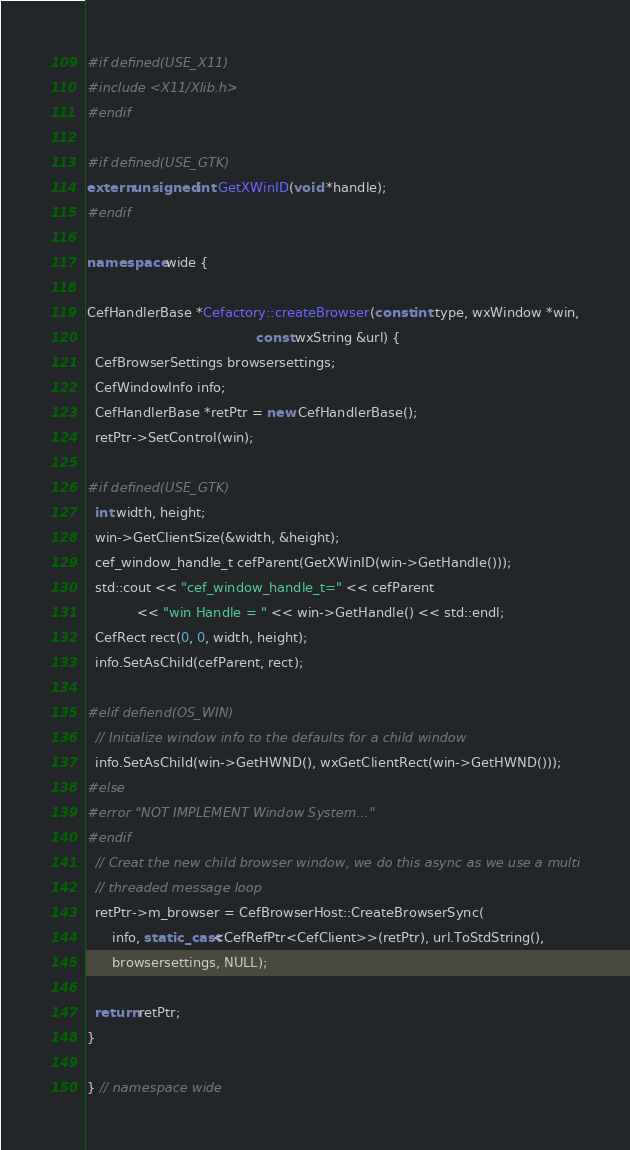Convert code to text. <code><loc_0><loc_0><loc_500><loc_500><_C++_>#if defined(USE_X11)
#include <X11/Xlib.h>
#endif

#if defined(USE_GTK)
extern unsigned int GetXWinID(void *handle);
#endif

namespace wide {

CefHandlerBase *Cefactory::createBrowser(const int type, wxWindow *win,
                                         const wxString &url) {
  CefBrowserSettings browsersettings;
  CefWindowInfo info;
  CefHandlerBase *retPtr = new CefHandlerBase();
  retPtr->SetControl(win);

#if defined(USE_GTK)
  int width, height;
  win->GetClientSize(&width, &height);
  cef_window_handle_t cefParent(GetXWinID(win->GetHandle()));
  std::cout << "cef_window_handle_t=" << cefParent
            << "win Handle = " << win->GetHandle() << std::endl;
  CefRect rect(0, 0, width, height);
  info.SetAsChild(cefParent, rect);

#elif defiend(OS_WIN)
  // Initialize window info to the defaults for a child window
  info.SetAsChild(win->GetHWND(), wxGetClientRect(win->GetHWND()));
#else
#error "NOT IMPLEMENT Window System..."
#endif
  // Creat the new child browser window, we do this async as we use a multi
  // threaded message loop
  retPtr->m_browser = CefBrowserHost::CreateBrowserSync(
      info, static_cast<CefRefPtr<CefClient>>(retPtr), url.ToStdString(),
      browsersettings, NULL);

  return retPtr;
}

} // namespace wide
</code> 